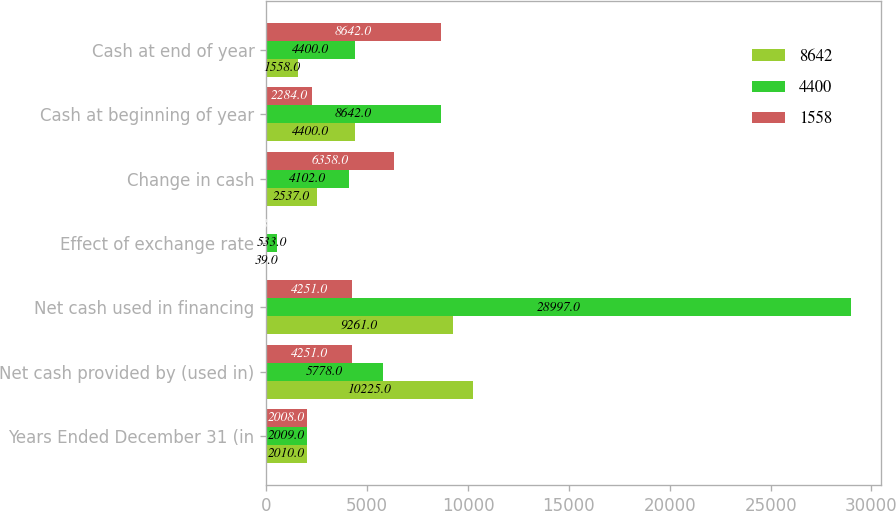<chart> <loc_0><loc_0><loc_500><loc_500><stacked_bar_chart><ecel><fcel>Years Ended December 31 (in<fcel>Net cash provided by (used in)<fcel>Net cash used in financing<fcel>Effect of exchange rate<fcel>Change in cash<fcel>Cash at beginning of year<fcel>Cash at end of year<nl><fcel>8642<fcel>2010<fcel>10225<fcel>9261<fcel>39<fcel>2537<fcel>4400<fcel>1558<nl><fcel>4400<fcel>2009<fcel>5778<fcel>28997<fcel>533<fcel>4102<fcel>8642<fcel>4400<nl><fcel>1558<fcel>2008<fcel>4251<fcel>4251<fcel>38<fcel>6358<fcel>2284<fcel>8642<nl></chart> 